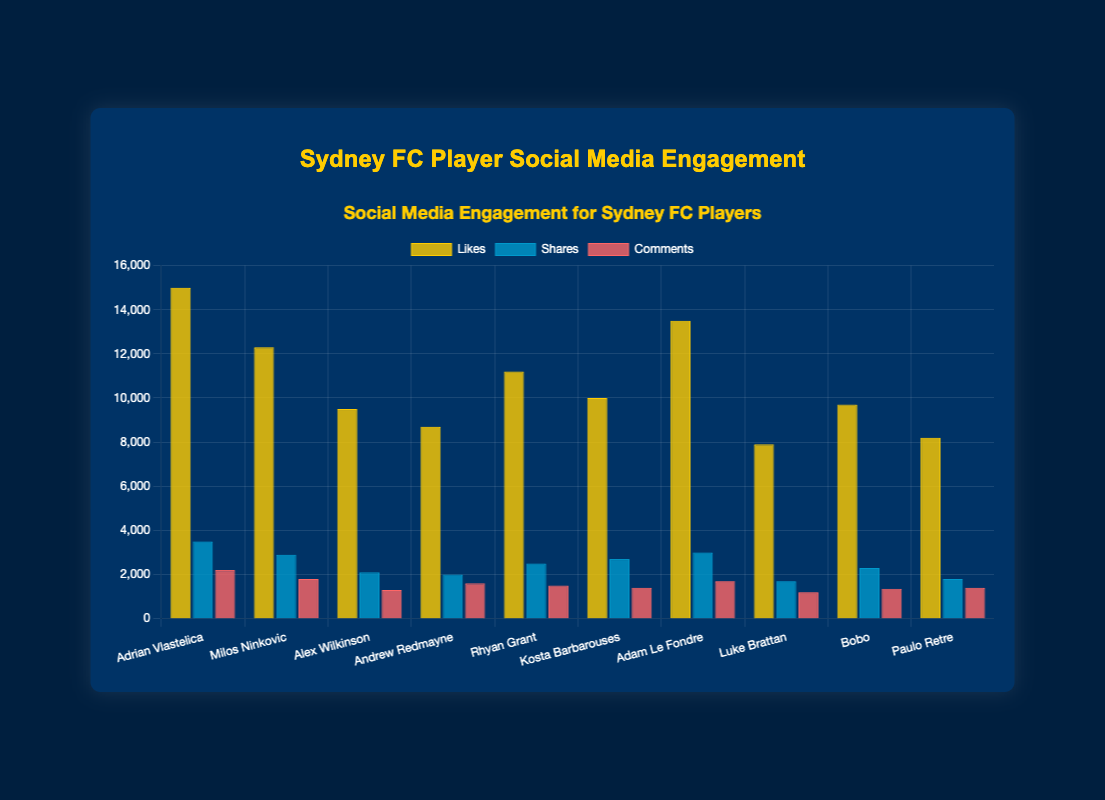Which player has the highest number of likes? Adrian Vlastelica has the highest number of likes with 15000. This can be seen by comparing the height of the "Likes" bars for each player in the chart.
Answer: Adrian Vlastelica Which player has the lowest number of comments? Luke Brattan has the lowest number of comments, with 1200. This is evident by comparing the height of the "Comments" bars for each player in the chart.
Answer: Luke Brattan How many more likes does Adrian Vlastelica have than Alex Wilkinson? Adrian Vlastelica has 15000 likes and Alex Wilkinson has 9500 likes. The difference is 15000 - 9500 = 5500 likes.
Answer: 5500 Who has more shares: Adam Le Fondre or Kosta Barbarouses? Adam Le Fondre has 3000 shares, while Kosta Barbarouses has 2700 shares. Comparing these values, Adam Le Fondre has more shares.
Answer: Adam Le Fondre What is the total number of likes for Adrian Vlastelica and Andrew Redmayne combined? Adrian Vlastelica has 15000 likes and Andrew Redmayne has 8700 likes. Adding these together gives 15000 + 8700 = 23700 likes.
Answer: 23700 Which player's "Comments" bar is closest in height to the "Comments" bar of Milos Ninkovic? The "Comments" bar for Rhyan Grant, which is 1500, is closest in height to the "Comments" bar for Milos Ninkovic, which is 1800, with the smallest difference of 300.
Answer: Rhyan Grant Which player has a higher combined engagement (likes, shares, comments): Luke Brattan or Paulo Retre? For Luke Brattan: likes (7900) + shares (1700) + comments (1200) = 10800. For Paulo Retre: likes (8200) + shares (1800) + comments (1400) = 11400. Comparing these, Paulo Retre has higher combined engagement.
Answer: Paulo Retre What is the average number of shares for the top three players by likes? The top three players by likes are Adrian Vlastelica (15000 likes, 3500 shares), Adam Le Fondre (13500 likes, 3000 shares), and Milos Ninkovic (12300 likes, 2900 shares). The average number of shares is (3500 + 3000 + 2900) / 3 = 3133.33 shares.
Answer: 3133.33 Arrange the players in descending order based on the total number of engagements (likes, shares, comments) Calculate the total engagements for each player and arrange:
1. Adrian Vlastelica: 15000 + 3500 + 2200 = 20700
2. Adam Le Fondre: 13500 + 3000 + 1700 = 18200
3. Milos Ninkovic: 12300 + 2900 + 1800 = 17000
4. Rhyan Grant: 11200 + 2500 + 1500 = 15200
5. Kosta Barbarouses: 10000 + 2700 + 1400 = 14100
6. Alex Wilkinson: 9500 + 2100 + 1300 = 12900
7. Bobo: 9700 + 2300 + 1350 = 13350
8. Andrew Redmayne: 8700 + 2000 + 1600 = 12300
9. Paulo Retre: 8200 + 1800 + 1400 = 11400
10. Luke Brattan: 7900 + 1700 + 1200 = 10800
Answer: Adrian Vlastelica, Adam Le Fondre, Milos Ninkovic, Rhyan Grant, Kosta Barbarouses, Bobo, Alex Wilkinson, Andrew Redmayne, Paulo Retre, Luke Brattan 